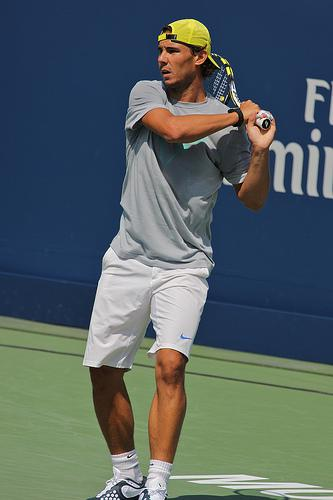Question: what sport is being played?
Choices:
A. Squash.
B. Ping Pong.
C. Badminton.
D. Tennis.
Answer with the letter. Answer: D Question: how is the man holding his racket?
Choices:
A. With both hands.
B. Under his arm.
C. With one hand.
D. With his teeth.
Answer with the letter. Answer: A Question: when was this photo taken?
Choices:
A. At night.
B. During the day.
C. Dawn.
D. Dusk.
Answer with the letter. Answer: B Question: what color is the man's hat?
Choices:
A. White.
B. Red.
C. Yellow.
D. Green.
Answer with the letter. Answer: C Question: what is on the man's wrist?
Choices:
A. A watch.
B. A bracelet.
C. A mosquito.
D. A sweatband.
Answer with the letter. Answer: A 